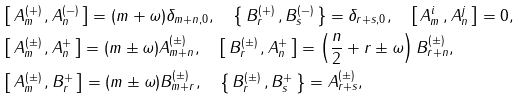<formula> <loc_0><loc_0><loc_500><loc_500>& \left [ \, A _ { m } ^ { ( + ) } \, , A _ { n } ^ { ( - ) } \, \right ] = ( m + \omega ) \delta _ { m + n , 0 } , \quad \left \{ \, B _ { r } ^ { ( + ) } \, , B _ { s } ^ { ( - ) } \, \right \} = \delta _ { r + s , 0 } , \quad \left [ \, A _ { m } ^ { i } \, , A _ { n } ^ { j } \, \right ] = 0 , \\ & \left [ \, A _ { m } ^ { ( \pm ) } \, , A _ { n } ^ { + } \, \right ] = ( m \pm \omega ) A _ { m + n } ^ { ( \pm ) } , \quad \left [ \, B _ { r } ^ { ( \pm ) } \, , A _ { n } ^ { + } \, \right ] = \left ( \frac { n } { 2 } + r \pm \omega \right ) B _ { r + n } ^ { ( \pm ) } , \\ & \left [ \, A _ { m } ^ { ( \pm ) } \, , B _ { r } ^ { + } \, \right ] = ( m \pm \omega ) B _ { m + r } ^ { ( \pm ) } , \quad \left \{ \, B _ { r } ^ { ( \pm ) } \, , B _ { s } ^ { + } \, \right \} = A _ { r + s } ^ { ( \pm ) } ,</formula> 